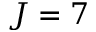Convert formula to latex. <formula><loc_0><loc_0><loc_500><loc_500>J = 7</formula> 